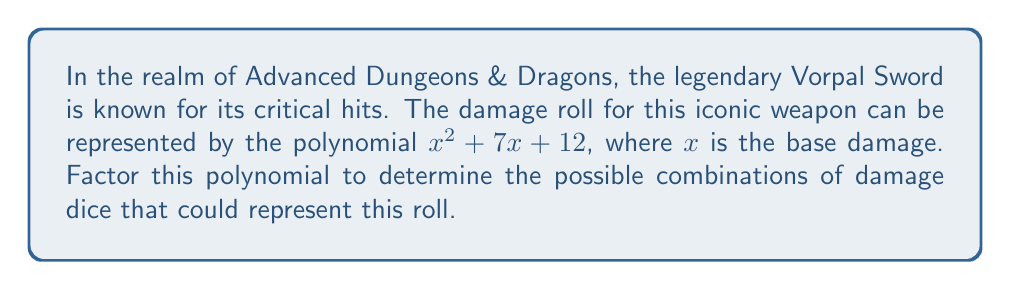Could you help me with this problem? To factor the polynomial $x^2 + 7x + 12$, we'll use the following steps:

1) First, we need to find two numbers that multiply to give the constant term (12) and add up to the coefficient of x (7).

2) The factors of 12 are: 1, 2, 3, 4, 6, and 12.

3) We need to find a pair of these factors that add up to 7. We can see that 3 and 4 satisfy this condition:
   3 * 4 = 12 and 3 + 4 = 7

4) Now we can rewrite the middle term of the polynomial:
   $x^2 + 7x + 12 = x^2 + 3x + 4x + 12$

5) We can now group these terms:
   $(x^2 + 3x) + (4x + 12)$

6) Factor out the common factors from each group:
   $x(x + 3) + 4(x + 3)$

7) We can now factor out the common binomial $(x + 3)$:
   $(x + 3)(x + 4)$

Therefore, the polynomial $x^2 + 7x + 12$ factors to $(x + 3)(x + 4)$.

In D&D terms, this could represent a damage roll of $(x+3)$ for one die and $(x+4)$ for another, where $x$ is the base damage. For example, this could be interpreted as rolling two dice, one that does 3 more damage than the base, and another that does 4 more damage than the base.
Answer: $(x + 3)(x + 4)$ 